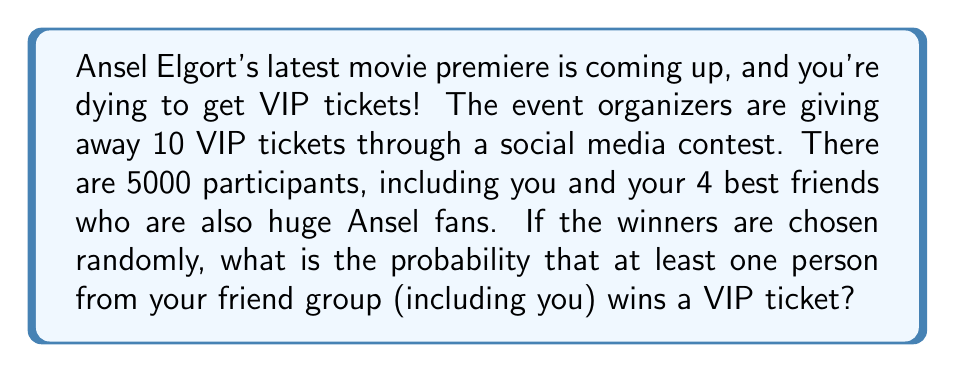Can you solve this math problem? Let's approach this step-by-step:

1) First, let's calculate the probability of none of you winning a ticket. This is easier than calculating the probability of at least one of you winning.

2) There are $\binom{5000}{10}$ ways to choose 10 winners out of 5000 participants.

3) There are 4995 participants who are not in your friend group. The number of ways to choose 10 winners from these 4995 people is $\binom{4995}{10}$.

4) The probability of none of your friend group winning is:

   $$P(\text{none win}) = \frac{\binom{4995}{10}}{\binom{5000}{10}}$$

5) Therefore, the probability of at least one person from your friend group winning is:

   $$P(\text{at least one wins}) = 1 - P(\text{none win}) = 1 - \frac{\binom{4995}{10}}{\binom{5000}{10}}$$

6) Let's calculate this:

   $$\binom{5000}{10} = 2.731031650028881 \times 10^{30}$$
   $$\binom{4995}{10} = 2.708721534526992 \times 10^{30}$$

   $$1 - \frac{2.708721534526992 \times 10^{30}}{2.731031650028881 \times 10^{30}} = 0.00818 \approx 0.0082$$

7) Converting to a percentage: $0.0082 \times 100\% = 0.82\%$
Answer: The probability that at least one person from your friend group wins a VIP ticket is approximately $0.82\%$ or $0.0082$. 